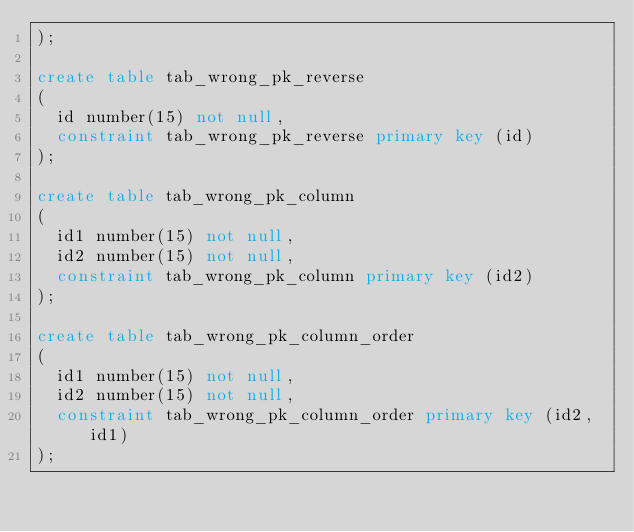<code> <loc_0><loc_0><loc_500><loc_500><_SQL_>);

create table tab_wrong_pk_reverse
(
  id number(15) not null,
  constraint tab_wrong_pk_reverse primary key (id)
);

create table tab_wrong_pk_column
(
  id1 number(15) not null,
  id2 number(15) not null,
  constraint tab_wrong_pk_column primary key (id2)
);

create table tab_wrong_pk_column_order
(
  id1 number(15) not null,
  id2 number(15) not null,
  constraint tab_wrong_pk_column_order primary key (id2,id1)
);



</code> 